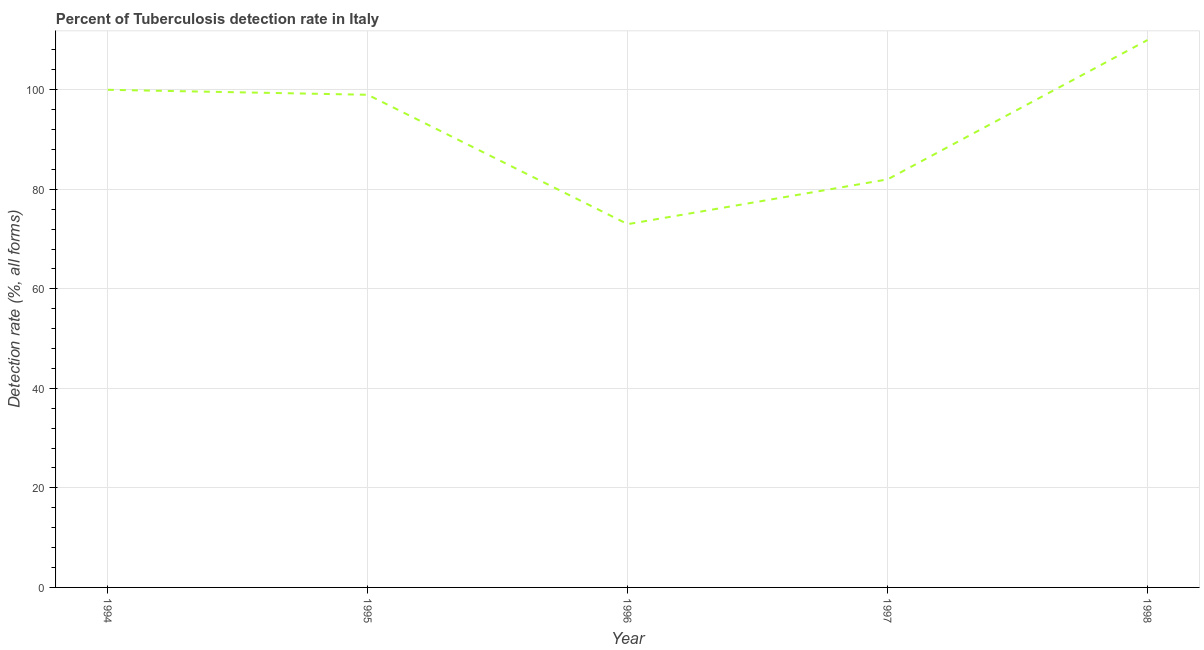What is the detection rate of tuberculosis in 1994?
Provide a succinct answer. 100. Across all years, what is the maximum detection rate of tuberculosis?
Offer a terse response. 110. Across all years, what is the minimum detection rate of tuberculosis?
Your response must be concise. 73. What is the sum of the detection rate of tuberculosis?
Your answer should be compact. 464. What is the difference between the detection rate of tuberculosis in 1994 and 1997?
Offer a terse response. 18. What is the average detection rate of tuberculosis per year?
Offer a very short reply. 92.8. What is the median detection rate of tuberculosis?
Your answer should be very brief. 99. Do a majority of the years between 1996 and 1997 (inclusive) have detection rate of tuberculosis greater than 56 %?
Ensure brevity in your answer.  Yes. What is the ratio of the detection rate of tuberculosis in 1997 to that in 1998?
Ensure brevity in your answer.  0.75. Is the detection rate of tuberculosis in 1996 less than that in 1998?
Offer a very short reply. Yes. Is the difference between the detection rate of tuberculosis in 1994 and 1996 greater than the difference between any two years?
Keep it short and to the point. No. What is the difference between the highest and the second highest detection rate of tuberculosis?
Your answer should be compact. 10. Is the sum of the detection rate of tuberculosis in 1995 and 1998 greater than the maximum detection rate of tuberculosis across all years?
Your answer should be very brief. Yes. What is the difference between the highest and the lowest detection rate of tuberculosis?
Your response must be concise. 37. Does the detection rate of tuberculosis monotonically increase over the years?
Your answer should be compact. No. How many lines are there?
Ensure brevity in your answer.  1. Does the graph contain any zero values?
Your response must be concise. No. Does the graph contain grids?
Ensure brevity in your answer.  Yes. What is the title of the graph?
Make the answer very short. Percent of Tuberculosis detection rate in Italy. What is the label or title of the Y-axis?
Make the answer very short. Detection rate (%, all forms). What is the Detection rate (%, all forms) in 1995?
Make the answer very short. 99. What is the Detection rate (%, all forms) in 1998?
Offer a very short reply. 110. What is the difference between the Detection rate (%, all forms) in 1995 and 1996?
Make the answer very short. 26. What is the difference between the Detection rate (%, all forms) in 1996 and 1997?
Your answer should be compact. -9. What is the difference between the Detection rate (%, all forms) in 1996 and 1998?
Your response must be concise. -37. What is the difference between the Detection rate (%, all forms) in 1997 and 1998?
Keep it short and to the point. -28. What is the ratio of the Detection rate (%, all forms) in 1994 to that in 1996?
Your response must be concise. 1.37. What is the ratio of the Detection rate (%, all forms) in 1994 to that in 1997?
Keep it short and to the point. 1.22. What is the ratio of the Detection rate (%, all forms) in 1994 to that in 1998?
Provide a short and direct response. 0.91. What is the ratio of the Detection rate (%, all forms) in 1995 to that in 1996?
Keep it short and to the point. 1.36. What is the ratio of the Detection rate (%, all forms) in 1995 to that in 1997?
Keep it short and to the point. 1.21. What is the ratio of the Detection rate (%, all forms) in 1996 to that in 1997?
Your answer should be very brief. 0.89. What is the ratio of the Detection rate (%, all forms) in 1996 to that in 1998?
Your answer should be compact. 0.66. What is the ratio of the Detection rate (%, all forms) in 1997 to that in 1998?
Make the answer very short. 0.74. 